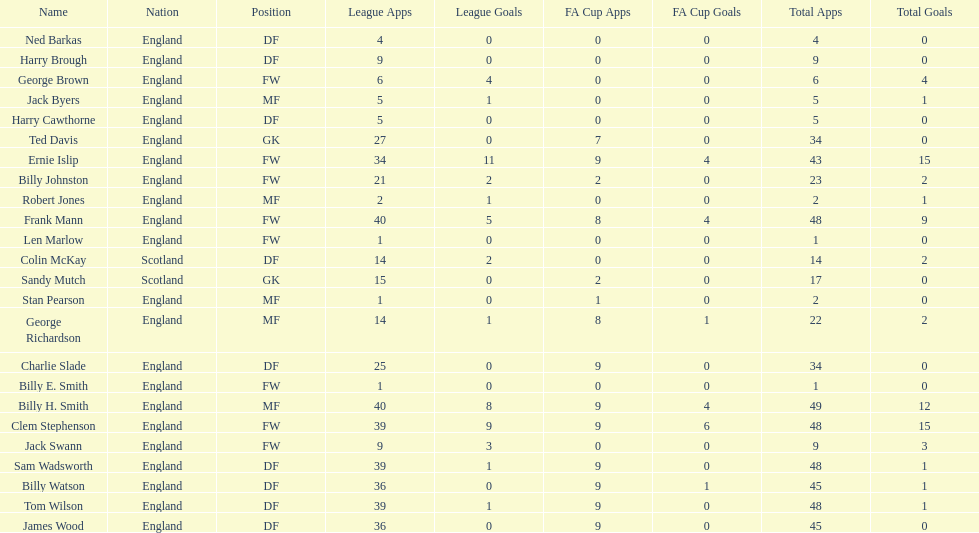Which position is listed the least amount of times on this chart? GK. 